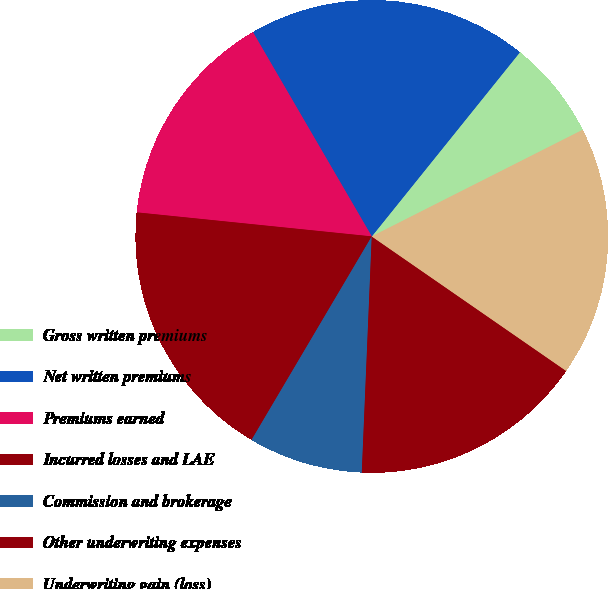<chart> <loc_0><loc_0><loc_500><loc_500><pie_chart><fcel>Gross written premiums<fcel>Net written premiums<fcel>Premiums earned<fcel>Incurred losses and LAE<fcel>Commission and brokerage<fcel>Other underwriting expenses<fcel>Underwriting gain (loss)<nl><fcel>6.77%<fcel>19.17%<fcel>14.99%<fcel>18.13%<fcel>7.82%<fcel>16.04%<fcel>17.08%<nl></chart> 